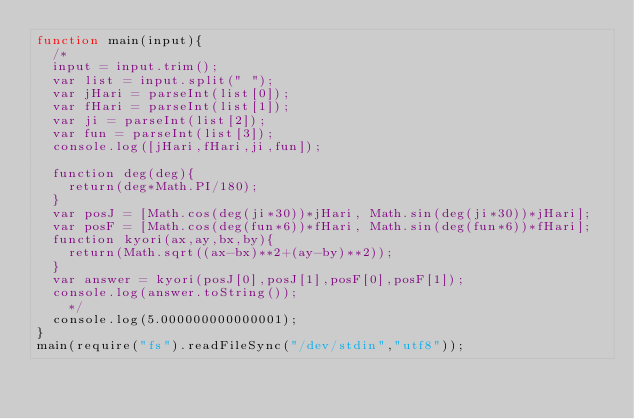Convert code to text. <code><loc_0><loc_0><loc_500><loc_500><_JavaScript_>function main(input){
  /*
	input = input.trim();
	var list = input.split(" ");
	var jHari = parseInt(list[0]);
	var fHari = parseInt(list[1]);
	var ji = parseInt(list[2]);
	var fun = parseInt(list[3]);
	console.log([jHari,fHari,ji,fun]);

	function deg(deg){
		return(deg*Math.PI/180);
	}
	var posJ = [Math.cos(deg(ji*30))*jHari, Math.sin(deg(ji*30))*jHari];
	var posF = [Math.cos(deg(fun*6))*fHari, Math.sin(deg(fun*6))*fHari];
	function kyori(ax,ay,bx,by){
		return(Math.sqrt((ax-bx)**2+(ay-by)**2));
	}
	var answer = kyori(posJ[0],posJ[1],posF[0],posF[1]);
	console.log(answer.toString());
    */
  console.log(5.000000000000001);
}
main(require("fs").readFileSync("/dev/stdin","utf8"));
</code> 